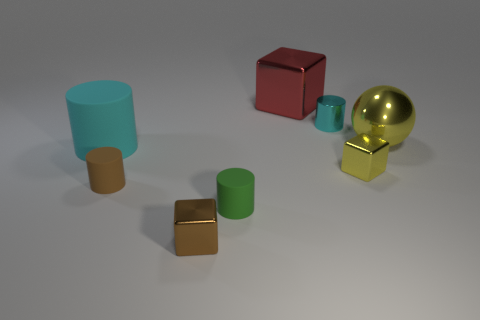Which objects in the scene are metallic? In this scene, the shiny gold sphere and the shiny silver cube appear to have metallic surfaces due to their reflective properties. 